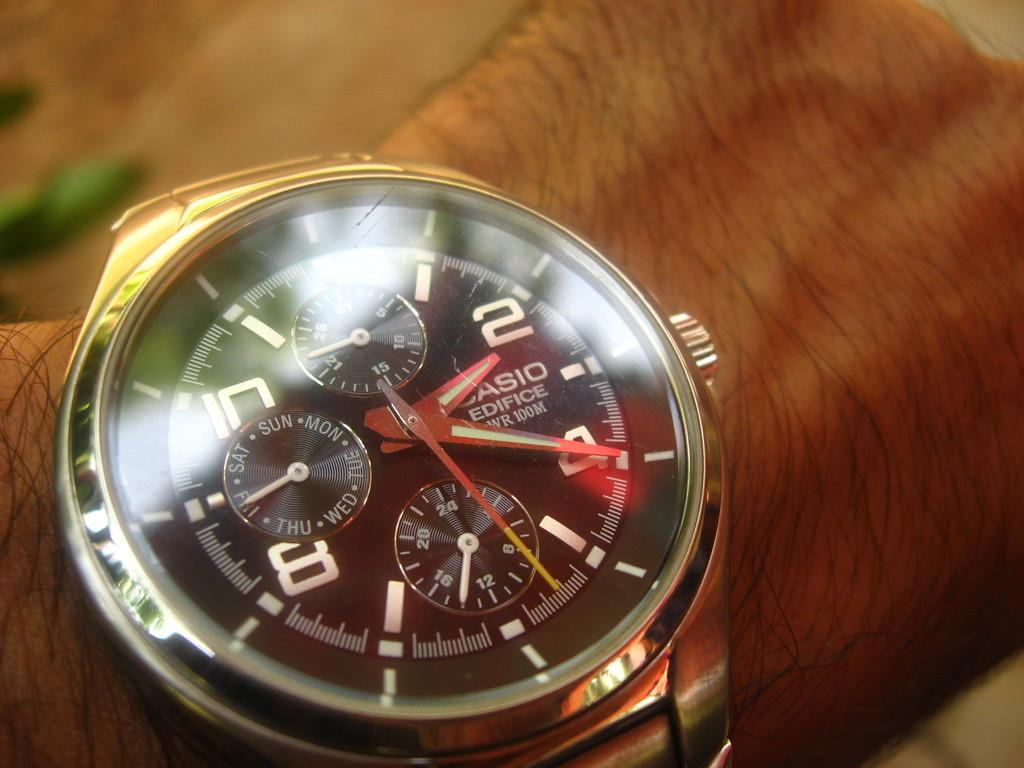<image>
Give a short and clear explanation of the subsequent image. A person wearing a Casio Edifice watch with many dials. 